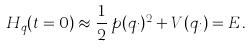Convert formula to latex. <formula><loc_0><loc_0><loc_500><loc_500>H _ { q } ( t = 0 ) \approx \frac { 1 } { 2 } \, p ( q _ { i } ) ^ { 2 } + V ( q _ { i } ) = E \, .</formula> 